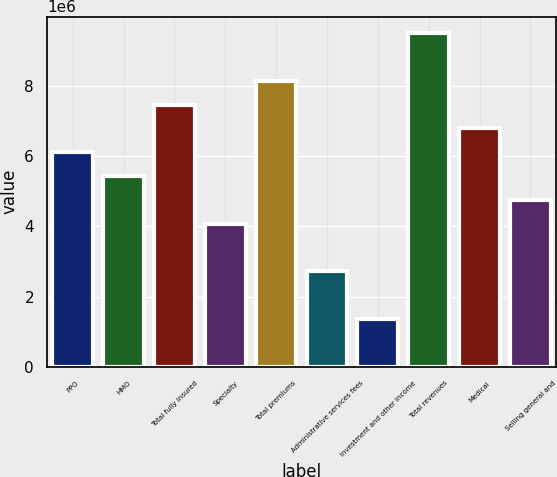Convert chart. <chart><loc_0><loc_0><loc_500><loc_500><bar_chart><fcel>PPO<fcel>HMO<fcel>Total fully insured<fcel>Specialty<fcel>Total premiums<fcel>Administrative services fees<fcel>Investment and other income<fcel>Total revenues<fcel>Medical<fcel>Selling general and<nl><fcel>6.11275e+06<fcel>5.43513e+06<fcel>7.46799e+06<fcel>4.07988e+06<fcel>8.14561e+06<fcel>2.72464e+06<fcel>1.3694e+06<fcel>9.50086e+06<fcel>6.79037e+06<fcel>4.75751e+06<nl></chart> 